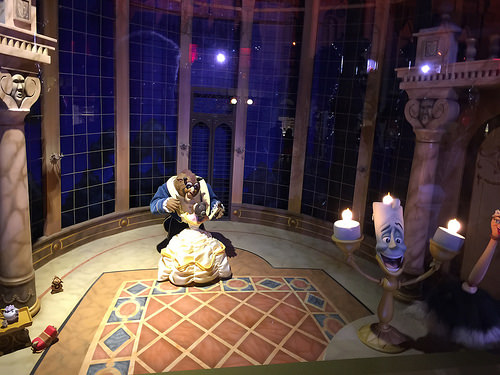<image>
Is there a window above the floor? No. The window is not positioned above the floor. The vertical arrangement shows a different relationship. 